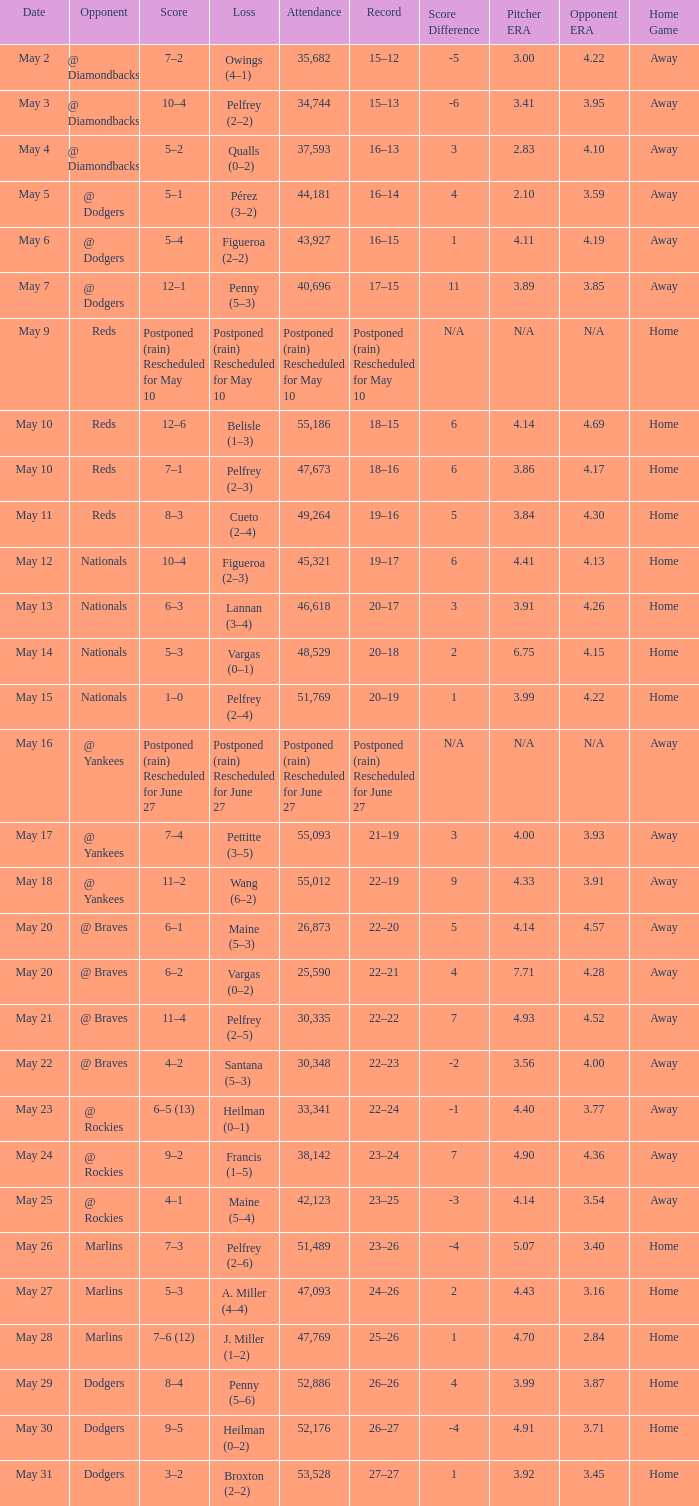Opponent of @ braves, and a Loss of pelfrey (2–5) had what score? 11–4. 